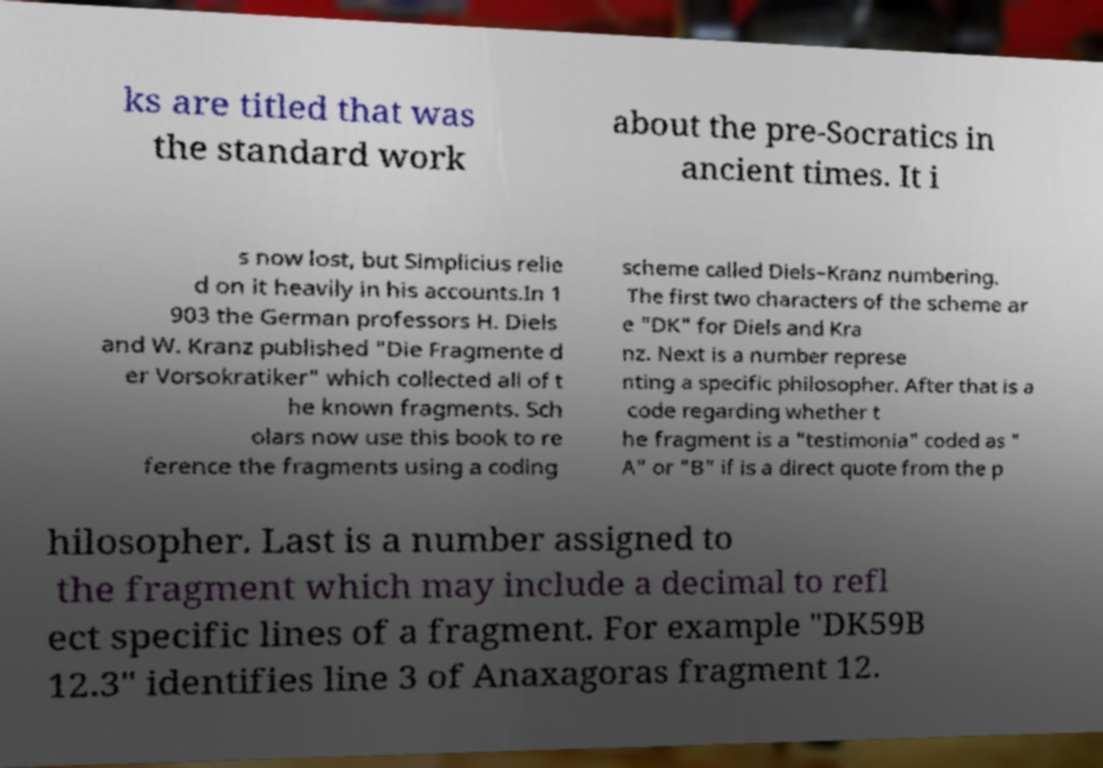Please identify and transcribe the text found in this image. ks are titled that was the standard work about the pre-Socratics in ancient times. It i s now lost, but Simplicius relie d on it heavily in his accounts.In 1 903 the German professors H. Diels and W. Kranz published "Die Fragmente d er Vorsokratiker" which collected all of t he known fragments. Sch olars now use this book to re ference the fragments using a coding scheme called Diels–Kranz numbering. The first two characters of the scheme ar e "DK" for Diels and Kra nz. Next is a number represe nting a specific philosopher. After that is a code regarding whether t he fragment is a "testimonia" coded as " A" or "B" if is a direct quote from the p hilosopher. Last is a number assigned to the fragment which may include a decimal to refl ect specific lines of a fragment. For example "DK59B 12.3" identifies line 3 of Anaxagoras fragment 12. 